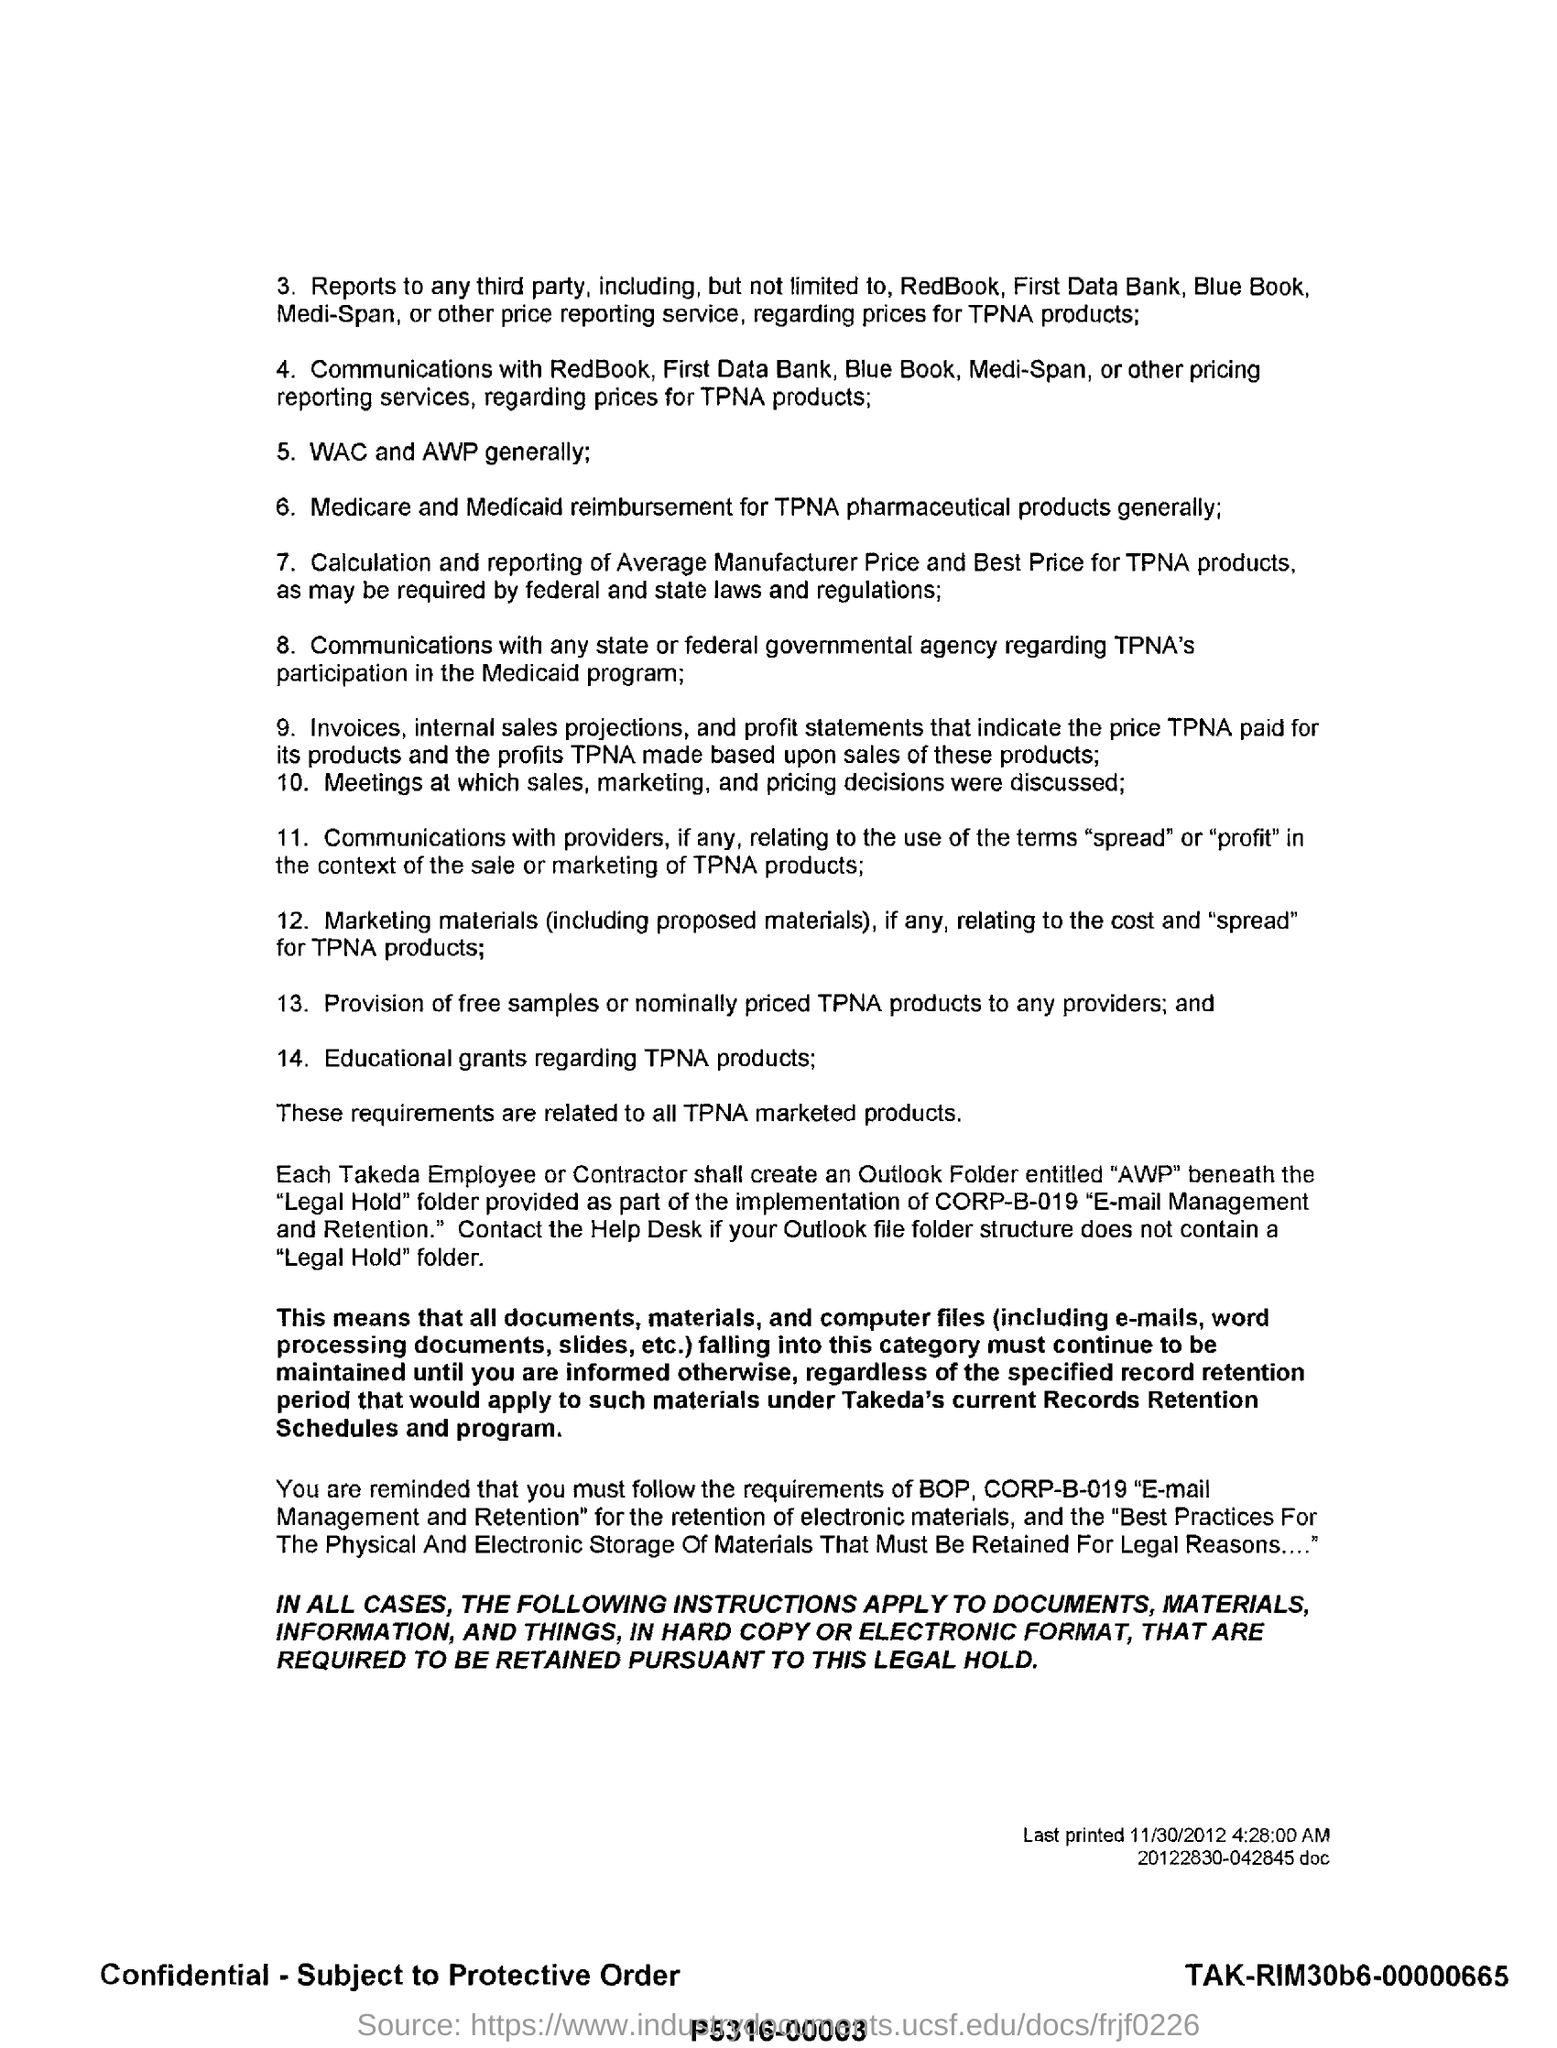Draw attention to some important aspects in this diagram. Reimbursement for TPNA pharmaceutical products is typically provided through Medicare and Medicaid. Education grants are available for products related to TPNA. On or about November 30, 2012, the date upon which this document was last printed, was the date on which the document was printed most recently. What is the fifth point? It generally refers to WAC and AWP. 